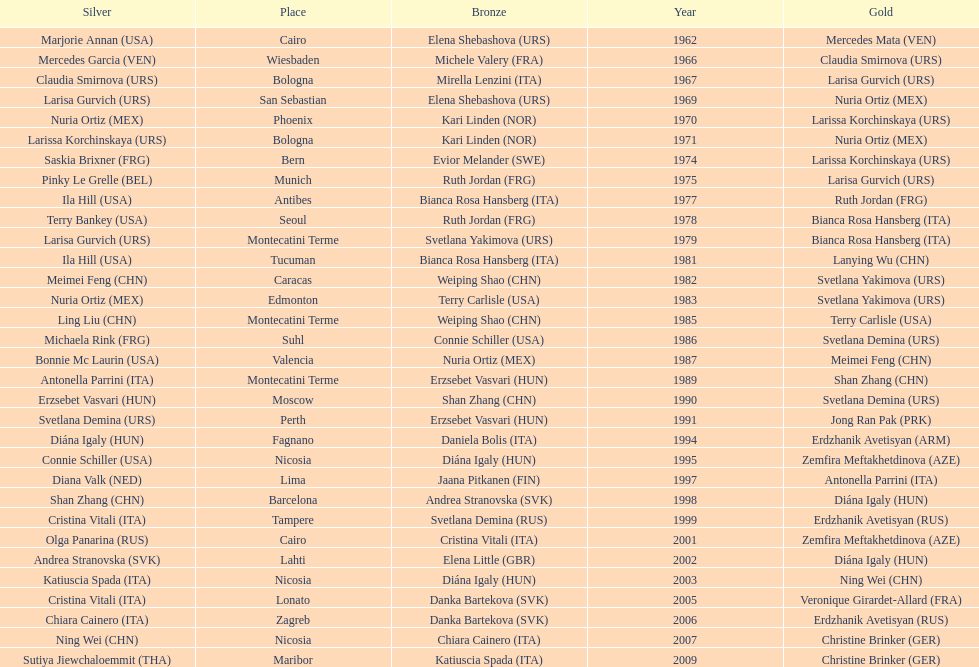Which country has won more gold medals: china or mexico? China. 